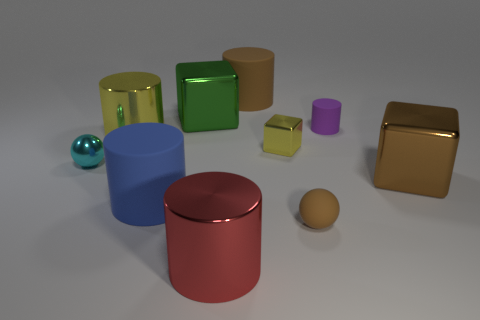Subtract 2 cylinders. How many cylinders are left? 3 Subtract all purple cylinders. How many cylinders are left? 4 Subtract all yellow cylinders. How many cylinders are left? 4 Subtract all yellow cylinders. Subtract all blue cubes. How many cylinders are left? 4 Subtract all balls. How many objects are left? 8 Subtract all big red shiny things. Subtract all big metallic blocks. How many objects are left? 7 Add 4 large rubber cylinders. How many large rubber cylinders are left? 6 Add 7 tiny purple objects. How many tiny purple objects exist? 8 Subtract 1 blue cylinders. How many objects are left? 9 